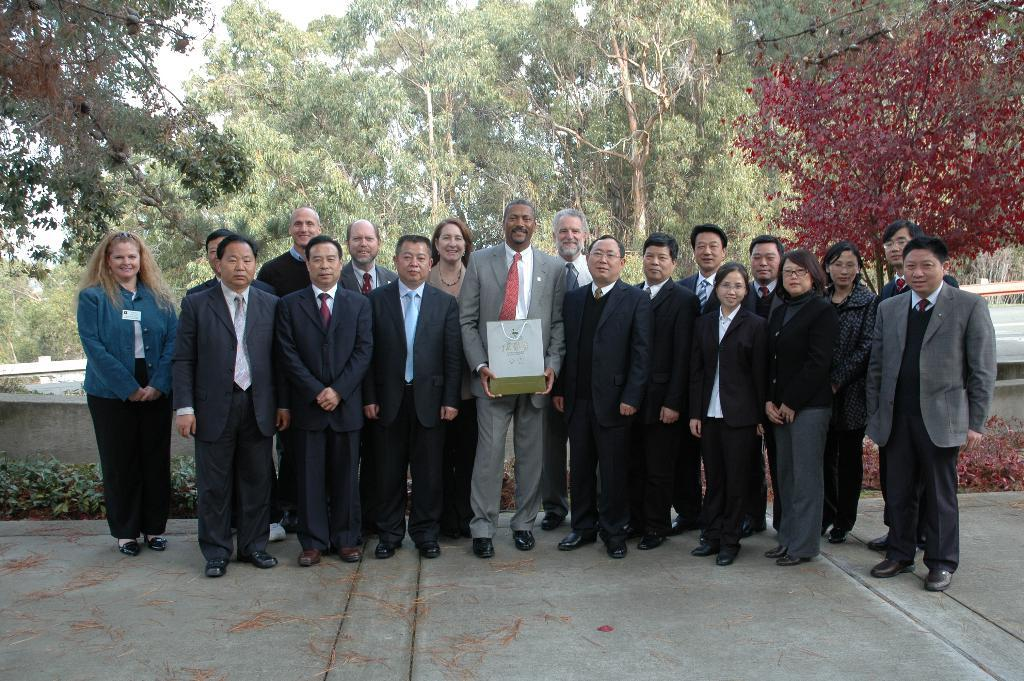How many people are in the image? There are people in the image, but the exact number is not specified. What is one person holding in the image? One person is holding a bag in the image. What type of vegetation can be seen in the image? There are plants and trees in the image. What is the background of the image? There is a wall in the image, and the sky is visible. Where is the doctor in the image? There is no doctor present in the image. What type of water feature can be seen in the image? There is no water feature present in the image. 